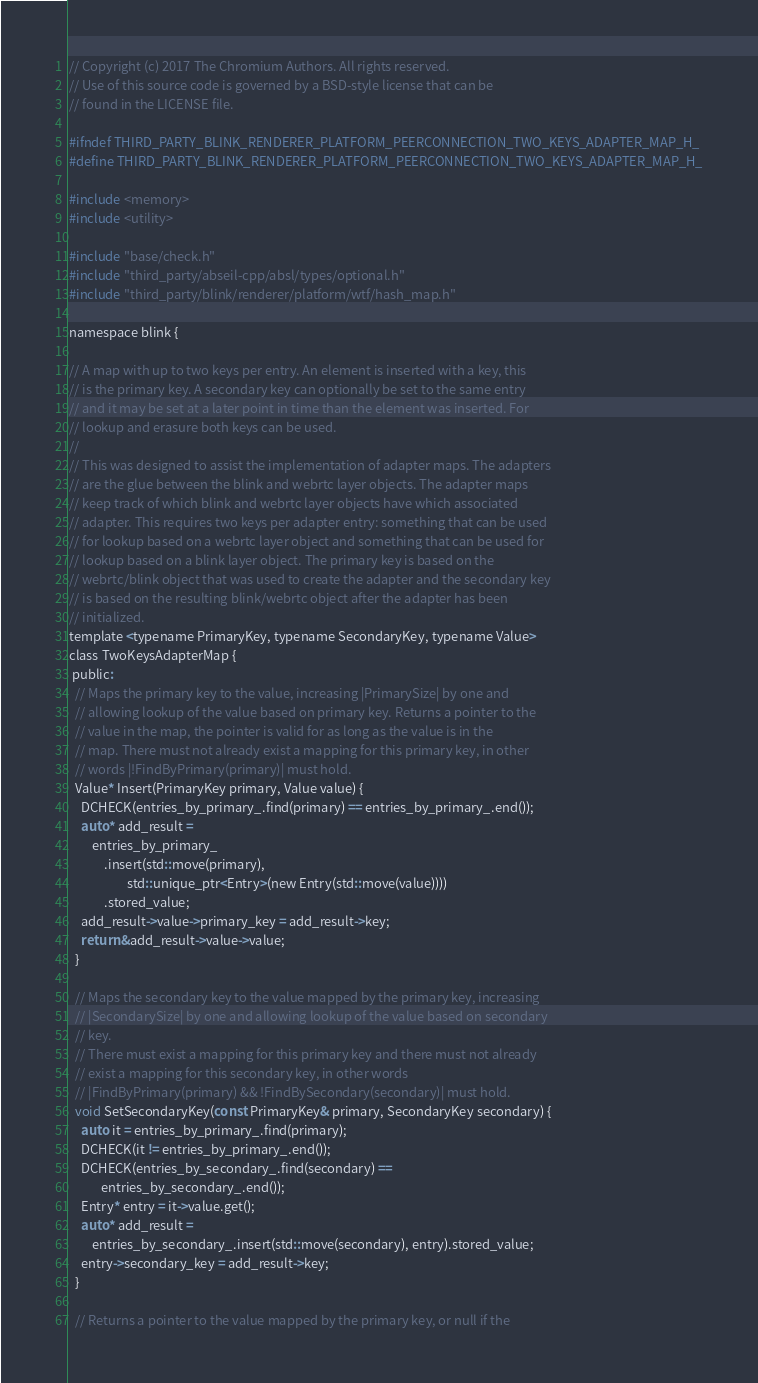<code> <loc_0><loc_0><loc_500><loc_500><_C_>// Copyright (c) 2017 The Chromium Authors. All rights reserved.
// Use of this source code is governed by a BSD-style license that can be
// found in the LICENSE file.

#ifndef THIRD_PARTY_BLINK_RENDERER_PLATFORM_PEERCONNECTION_TWO_KEYS_ADAPTER_MAP_H_
#define THIRD_PARTY_BLINK_RENDERER_PLATFORM_PEERCONNECTION_TWO_KEYS_ADAPTER_MAP_H_

#include <memory>
#include <utility>

#include "base/check.h"
#include "third_party/abseil-cpp/absl/types/optional.h"
#include "third_party/blink/renderer/platform/wtf/hash_map.h"

namespace blink {

// A map with up to two keys per entry. An element is inserted with a key, this
// is the primary key. A secondary key can optionally be set to the same entry
// and it may be set at a later point in time than the element was inserted. For
// lookup and erasure both keys can be used.
//
// This was designed to assist the implementation of adapter maps. The adapters
// are the glue between the blink and webrtc layer objects. The adapter maps
// keep track of which blink and webrtc layer objects have which associated
// adapter. This requires two keys per adapter entry: something that can be used
// for lookup based on a webrtc layer object and something that can be used for
// lookup based on a blink layer object. The primary key is based on the
// webrtc/blink object that was used to create the adapter and the secondary key
// is based on the resulting blink/webrtc object after the adapter has been
// initialized.
template <typename PrimaryKey, typename SecondaryKey, typename Value>
class TwoKeysAdapterMap {
 public:
  // Maps the primary key to the value, increasing |PrimarySize| by one and
  // allowing lookup of the value based on primary key. Returns a pointer to the
  // value in the map, the pointer is valid for as long as the value is in the
  // map. There must not already exist a mapping for this primary key, in other
  // words |!FindByPrimary(primary)| must hold.
  Value* Insert(PrimaryKey primary, Value value) {
    DCHECK(entries_by_primary_.find(primary) == entries_by_primary_.end());
    auto* add_result =
        entries_by_primary_
            .insert(std::move(primary),
                    std::unique_ptr<Entry>(new Entry(std::move(value))))
            .stored_value;
    add_result->value->primary_key = add_result->key;
    return &add_result->value->value;
  }

  // Maps the secondary key to the value mapped by the primary key, increasing
  // |SecondarySize| by one and allowing lookup of the value based on secondary
  // key.
  // There must exist a mapping for this primary key and there must not already
  // exist a mapping for this secondary key, in other words
  // |FindByPrimary(primary) && !FindBySecondary(secondary)| must hold.
  void SetSecondaryKey(const PrimaryKey& primary, SecondaryKey secondary) {
    auto it = entries_by_primary_.find(primary);
    DCHECK(it != entries_by_primary_.end());
    DCHECK(entries_by_secondary_.find(secondary) ==
           entries_by_secondary_.end());
    Entry* entry = it->value.get();
    auto* add_result =
        entries_by_secondary_.insert(std::move(secondary), entry).stored_value;
    entry->secondary_key = add_result->key;
  }

  // Returns a pointer to the value mapped by the primary key, or null if the</code> 